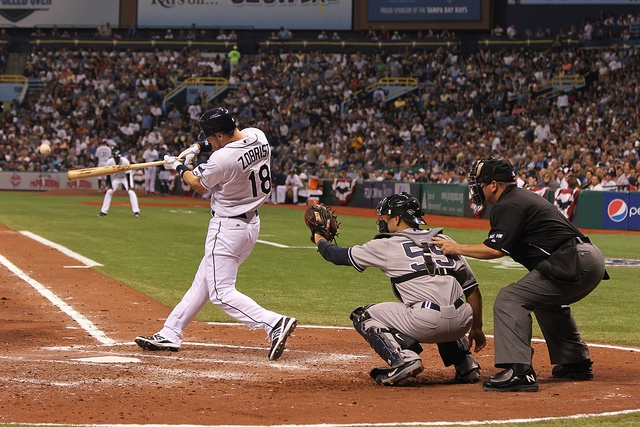Describe the objects in this image and their specific colors. I can see people in purple, black, gray, and maroon tones, people in purple, black, gray, and maroon tones, people in purple, black, darkgray, and gray tones, people in purple, lavender, black, darkgray, and gray tones, and people in purple, lavender, gray, black, and darkgray tones in this image. 